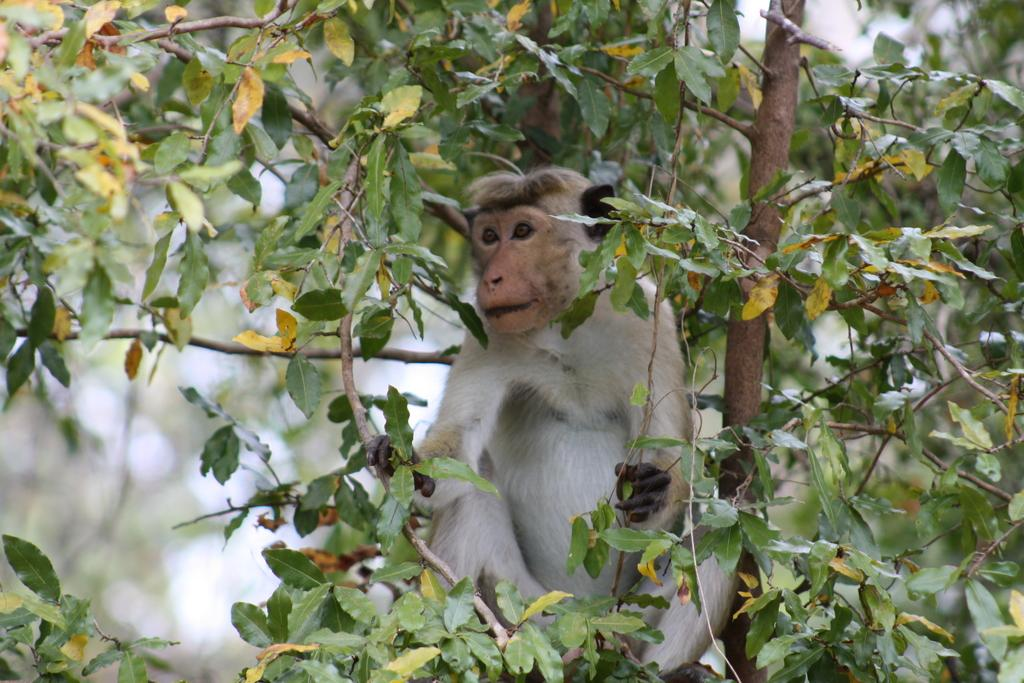What animal is present in the image? There is a monkey in the image. Where is the monkey located? The monkey is on a tree. Can you describe the background of the image? The background of the image is blurred. What type of cord is being used by the monkey in the image? There is no cord present in the image; the monkey is simply sitting on a tree. 